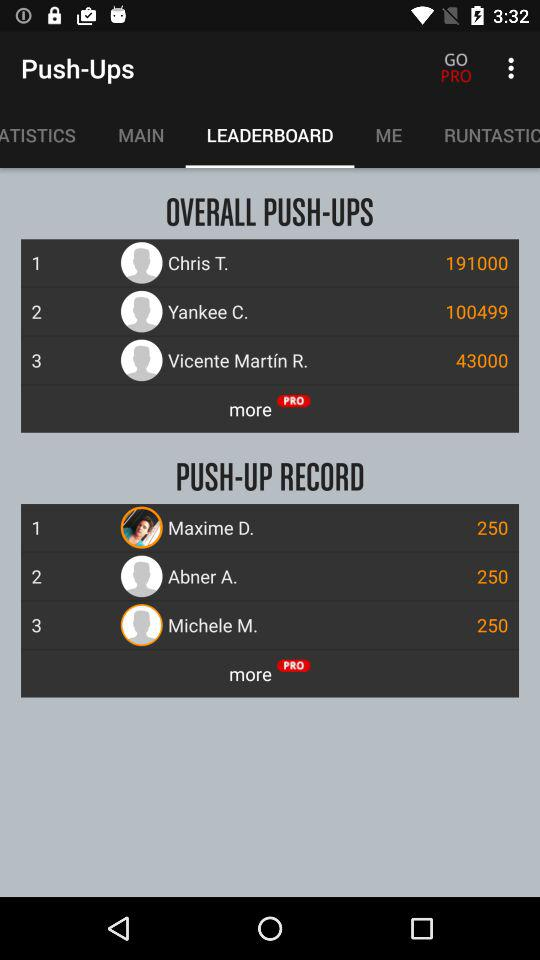What is the push-up record of "Abner A."? The push-up record of "Abner A." is 250. 